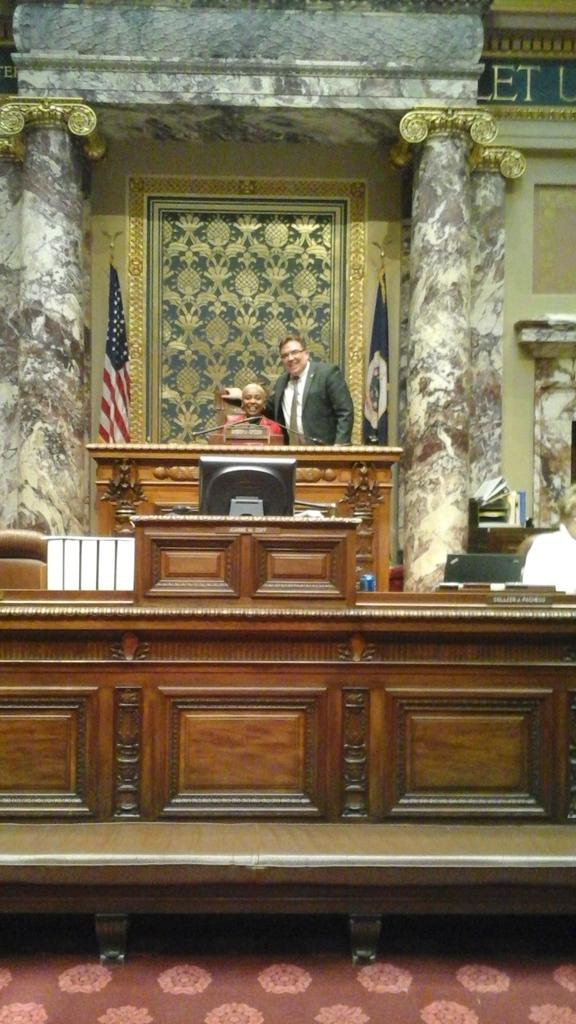What is the woman doing in the image? The woman is sitting on a chair in the image. What is the man doing in the image? The man is standing in the image. What object is present on the table? There is a microphone on the table in the image. What architectural features can be seen in the background? In the background, there are pillars and a cupboard. What type of shoe is the woman wearing in the image? There is no information about the woman's shoes in the image, so we cannot determine what type of shoe she is wearing. How many sacks are visible in the image? There are no sacks present in the image. 